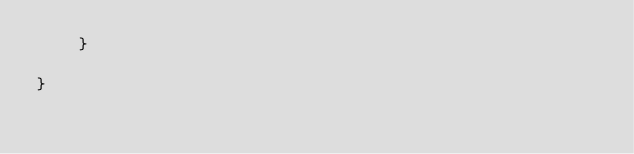Convert code to text. <code><loc_0><loc_0><loc_500><loc_500><_C#_>    }

}
</code> 